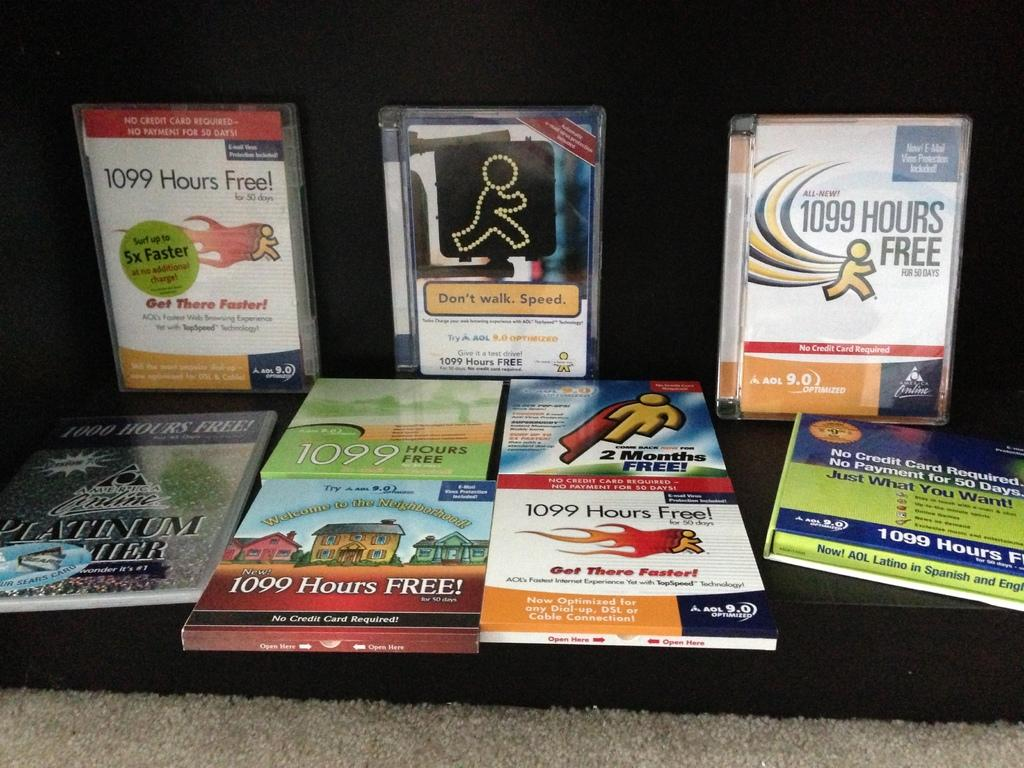<image>
Give a short and clear explanation of the subsequent image. AOL gave away things like 1099 Hours Free with No Credit Card Required! 